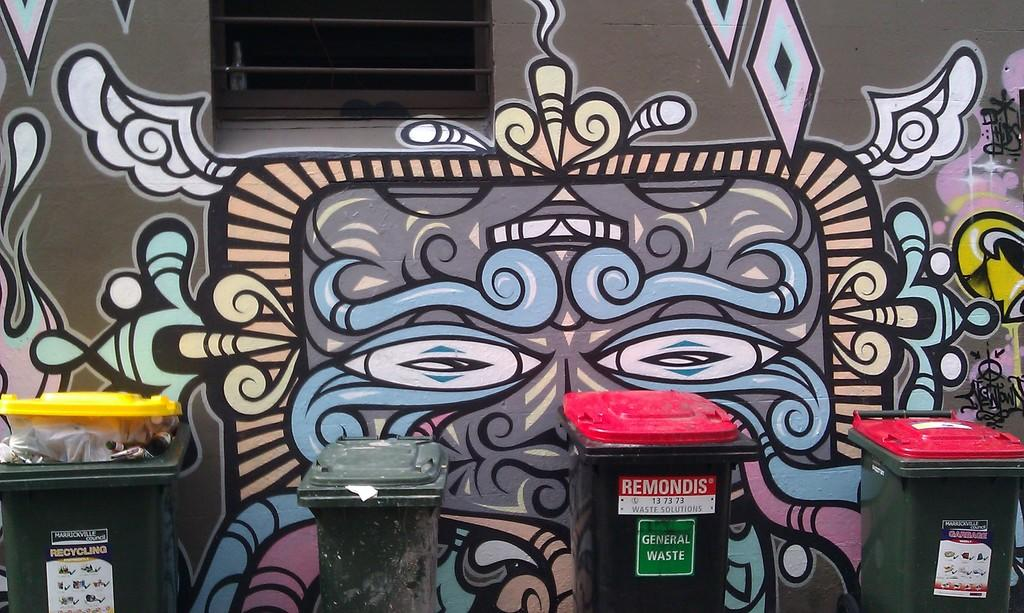<image>
Write a terse but informative summary of the picture. Garbage can with red top that says "General Waste" in front of a wall. 